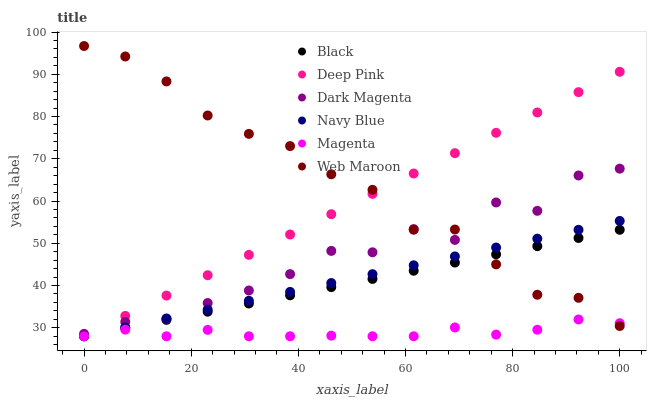Does Magenta have the minimum area under the curve?
Answer yes or no. Yes. Does Web Maroon have the maximum area under the curve?
Answer yes or no. Yes. Does Dark Magenta have the minimum area under the curve?
Answer yes or no. No. Does Dark Magenta have the maximum area under the curve?
Answer yes or no. No. Is Navy Blue the smoothest?
Answer yes or no. Yes. Is Dark Magenta the roughest?
Answer yes or no. Yes. Is Dark Magenta the smoothest?
Answer yes or no. No. Is Navy Blue the roughest?
Answer yes or no. No. Does Deep Pink have the lowest value?
Answer yes or no. Yes. Does Dark Magenta have the lowest value?
Answer yes or no. No. Does Web Maroon have the highest value?
Answer yes or no. Yes. Does Dark Magenta have the highest value?
Answer yes or no. No. Is Magenta less than Dark Magenta?
Answer yes or no. Yes. Is Dark Magenta greater than Black?
Answer yes or no. Yes. Does Magenta intersect Web Maroon?
Answer yes or no. Yes. Is Magenta less than Web Maroon?
Answer yes or no. No. Is Magenta greater than Web Maroon?
Answer yes or no. No. Does Magenta intersect Dark Magenta?
Answer yes or no. No. 